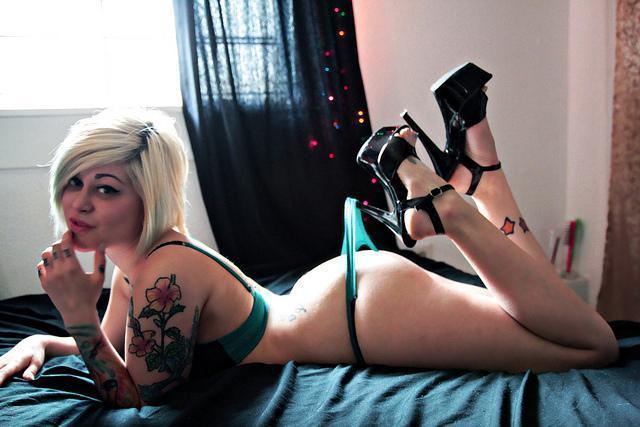How many cups are being held by a person?
Give a very brief answer. 0. 